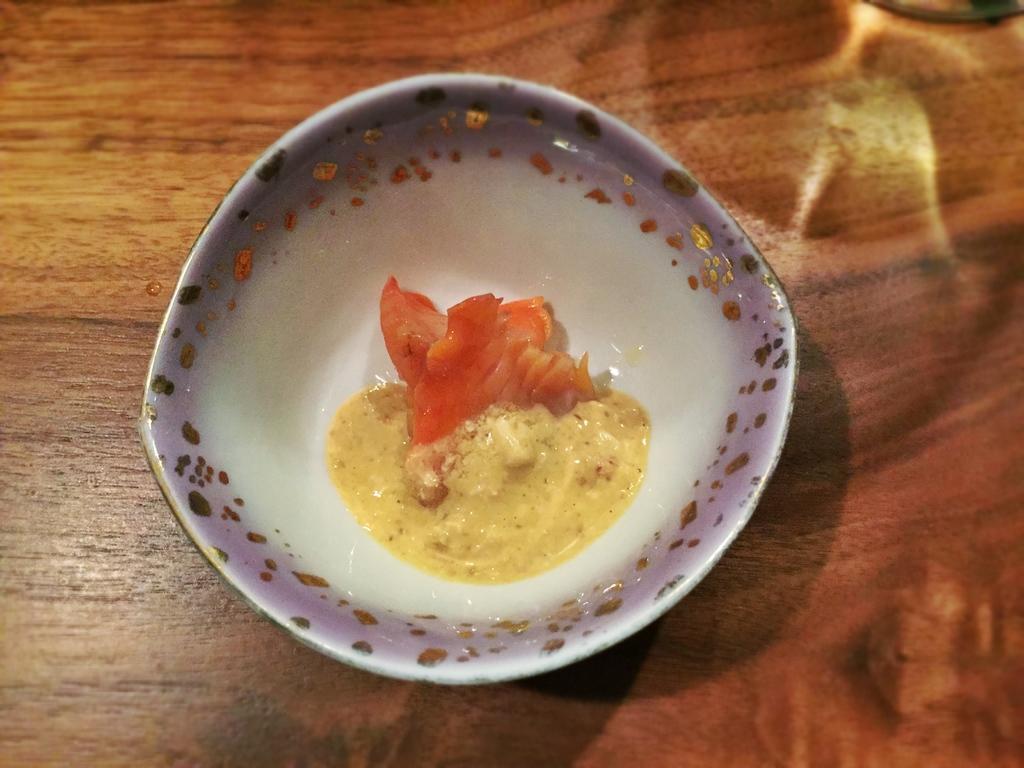Can you describe this image briefly? In the image we can see a table, on the table we can see a bowl. In the bowl we can see some food. 